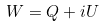Convert formula to latex. <formula><loc_0><loc_0><loc_500><loc_500>W = Q + i U</formula> 